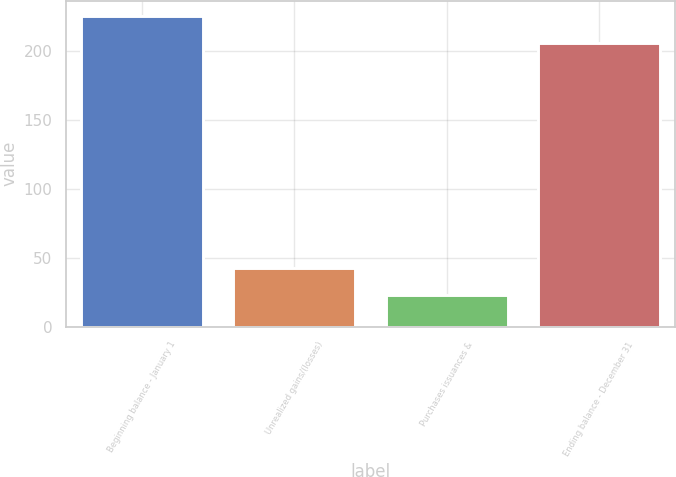<chart> <loc_0><loc_0><loc_500><loc_500><bar_chart><fcel>Beginning balance - January 1<fcel>Unrealized gains/(losses)<fcel>Purchases issuances &<fcel>Ending balance - December 31<nl><fcel>225.5<fcel>42.5<fcel>23<fcel>206<nl></chart> 